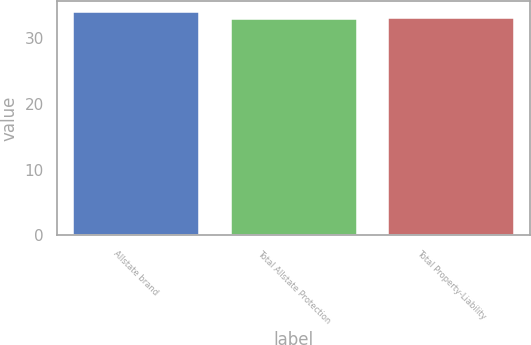<chart> <loc_0><loc_0><loc_500><loc_500><bar_chart><fcel>Allstate brand<fcel>Total Allstate Protection<fcel>Total Property-Liability<nl><fcel>34<fcel>33<fcel>33.1<nl></chart> 